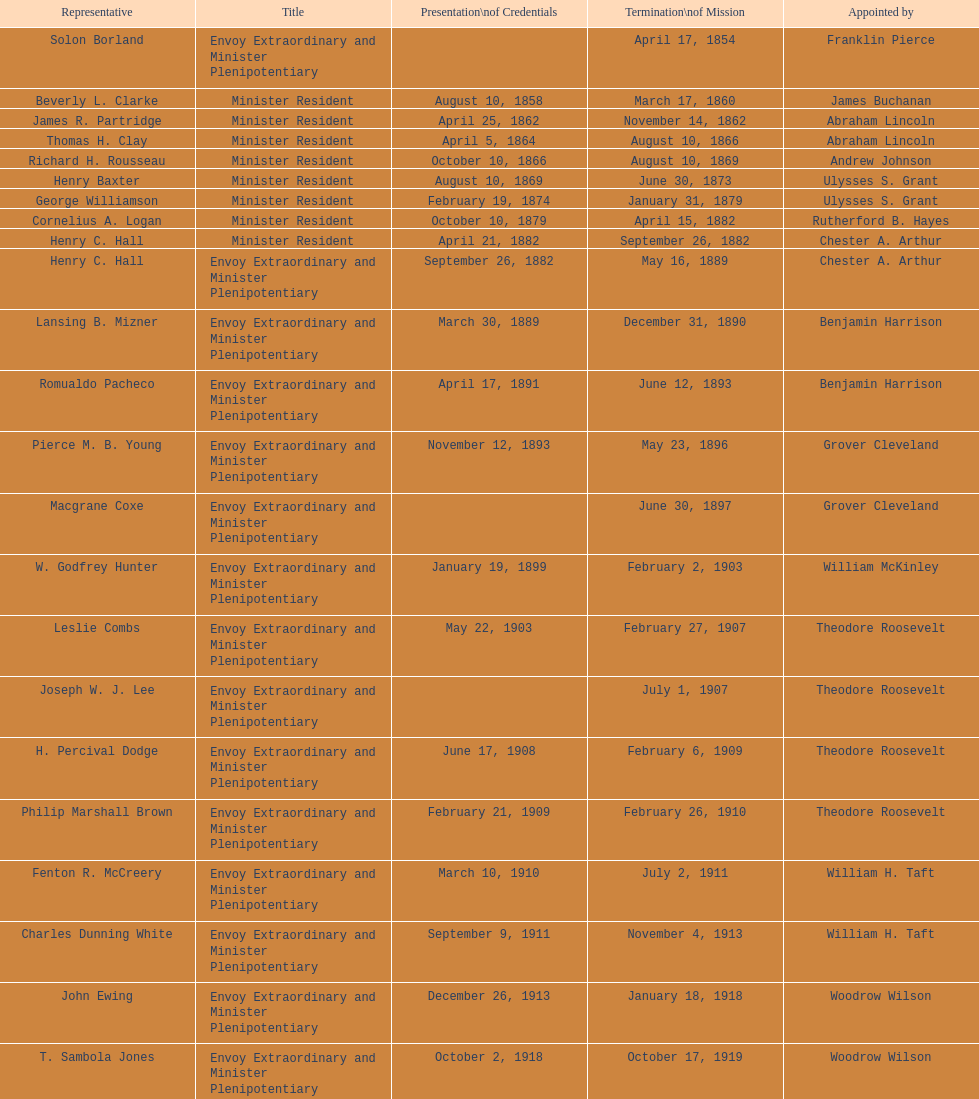Help me parse the entirety of this table. {'header': ['Representative', 'Title', 'Presentation\\nof Credentials', 'Termination\\nof Mission', 'Appointed by'], 'rows': [['Solon Borland', 'Envoy Extraordinary and Minister Plenipotentiary', '', 'April 17, 1854', 'Franklin Pierce'], ['Beverly L. Clarke', 'Minister Resident', 'August 10, 1858', 'March 17, 1860', 'James Buchanan'], ['James R. Partridge', 'Minister Resident', 'April 25, 1862', 'November 14, 1862', 'Abraham Lincoln'], ['Thomas H. Clay', 'Minister Resident', 'April 5, 1864', 'August 10, 1866', 'Abraham Lincoln'], ['Richard H. Rousseau', 'Minister Resident', 'October 10, 1866', 'August 10, 1869', 'Andrew Johnson'], ['Henry Baxter', 'Minister Resident', 'August 10, 1869', 'June 30, 1873', 'Ulysses S. Grant'], ['George Williamson', 'Minister Resident', 'February 19, 1874', 'January 31, 1879', 'Ulysses S. Grant'], ['Cornelius A. Logan', 'Minister Resident', 'October 10, 1879', 'April 15, 1882', 'Rutherford B. Hayes'], ['Henry C. Hall', 'Minister Resident', 'April 21, 1882', 'September 26, 1882', 'Chester A. Arthur'], ['Henry C. Hall', 'Envoy Extraordinary and Minister Plenipotentiary', 'September 26, 1882', 'May 16, 1889', 'Chester A. Arthur'], ['Lansing B. Mizner', 'Envoy Extraordinary and Minister Plenipotentiary', 'March 30, 1889', 'December 31, 1890', 'Benjamin Harrison'], ['Romualdo Pacheco', 'Envoy Extraordinary and Minister Plenipotentiary', 'April 17, 1891', 'June 12, 1893', 'Benjamin Harrison'], ['Pierce M. B. Young', 'Envoy Extraordinary and Minister Plenipotentiary', 'November 12, 1893', 'May 23, 1896', 'Grover Cleveland'], ['Macgrane Coxe', 'Envoy Extraordinary and Minister Plenipotentiary', '', 'June 30, 1897', 'Grover Cleveland'], ['W. Godfrey Hunter', 'Envoy Extraordinary and Minister Plenipotentiary', 'January 19, 1899', 'February 2, 1903', 'William McKinley'], ['Leslie Combs', 'Envoy Extraordinary and Minister Plenipotentiary', 'May 22, 1903', 'February 27, 1907', 'Theodore Roosevelt'], ['Joseph W. J. Lee', 'Envoy Extraordinary and Minister Plenipotentiary', '', 'July 1, 1907', 'Theodore Roosevelt'], ['H. Percival Dodge', 'Envoy Extraordinary and Minister Plenipotentiary', 'June 17, 1908', 'February 6, 1909', 'Theodore Roosevelt'], ['Philip Marshall Brown', 'Envoy Extraordinary and Minister Plenipotentiary', 'February 21, 1909', 'February 26, 1910', 'Theodore Roosevelt'], ['Fenton R. McCreery', 'Envoy Extraordinary and Minister Plenipotentiary', 'March 10, 1910', 'July 2, 1911', 'William H. Taft'], ['Charles Dunning White', 'Envoy Extraordinary and Minister Plenipotentiary', 'September 9, 1911', 'November 4, 1913', 'William H. Taft'], ['John Ewing', 'Envoy Extraordinary and Minister Plenipotentiary', 'December 26, 1913', 'January 18, 1918', 'Woodrow Wilson'], ['T. Sambola Jones', 'Envoy Extraordinary and Minister Plenipotentiary', 'October 2, 1918', 'October 17, 1919', 'Woodrow Wilson'], ['Franklin E. Morales', 'Envoy Extraordinary and Minister Plenipotentiary', 'January 18, 1922', 'March 2, 1925', 'Warren G. Harding'], ['George T. Summerlin', 'Envoy Extraordinary and Minister Plenipotentiary', 'November 21, 1925', 'December 17, 1929', 'Calvin Coolidge'], ['Julius G. Lay', 'Envoy Extraordinary and Minister Plenipotentiary', 'May 31, 1930', 'March 17, 1935', 'Herbert Hoover'], ['Leo J. Keena', 'Envoy Extraordinary and Minister Plenipotentiary', 'July 19, 1935', 'May 1, 1937', 'Franklin D. Roosevelt'], ['John Draper Erwin', 'Envoy Extraordinary and Minister Plenipotentiary', 'September 8, 1937', 'April 27, 1943', 'Franklin D. Roosevelt'], ['John Draper Erwin', 'Ambassador Extraordinary and Plenipotentiary', 'April 27, 1943', 'April 16, 1947', 'Franklin D. Roosevelt'], ['Paul C. Daniels', 'Ambassador Extraordinary and Plenipotentiary', 'June 23, 1947', 'October 30, 1947', 'Harry S. Truman'], ['Herbert S. Bursley', 'Ambassador Extraordinary and Plenipotentiary', 'May 15, 1948', 'December 12, 1950', 'Harry S. Truman'], ['John Draper Erwin', 'Ambassador Extraordinary and Plenipotentiary', 'March 14, 1951', 'February 28, 1954', 'Harry S. Truman'], ['Whiting Willauer', 'Ambassador Extraordinary and Plenipotentiary', 'March 5, 1954', 'March 24, 1958', 'Dwight D. Eisenhower'], ['Robert Newbegin', 'Ambassador Extraordinary and Plenipotentiary', 'April 30, 1958', 'August 3, 1960', 'Dwight D. Eisenhower'], ['Charles R. Burrows', 'Ambassador Extraordinary and Plenipotentiary', 'November 3, 1960', 'June 28, 1965', 'Dwight D. Eisenhower'], ['Joseph J. Jova', 'Ambassador Extraordinary and Plenipotentiary', 'July 12, 1965', 'June 21, 1969', 'Lyndon B. Johnson'], ['Hewson A. Ryan', 'Ambassador Extraordinary and Plenipotentiary', 'November 5, 1969', 'May 30, 1973', 'Richard Nixon'], ['Phillip V. Sanchez', 'Ambassador Extraordinary and Plenipotentiary', 'June 15, 1973', 'July 17, 1976', 'Richard Nixon'], ['Ralph E. Becker', 'Ambassador Extraordinary and Plenipotentiary', 'October 27, 1976', 'August 1, 1977', 'Gerald Ford'], ['Mari-Luci Jaramillo', 'Ambassador Extraordinary and Plenipotentiary', 'October 27, 1977', 'September 19, 1980', 'Jimmy Carter'], ['Jack R. Binns', 'Ambassador Extraordinary and Plenipotentiary', 'October 10, 1980', 'October 31, 1981', 'Jimmy Carter'], ['John D. Negroponte', 'Ambassador Extraordinary and Plenipotentiary', 'November 11, 1981', 'May 30, 1985', 'Ronald Reagan'], ['John Arthur Ferch', 'Ambassador Extraordinary and Plenipotentiary', 'August 22, 1985', 'July 9, 1986', 'Ronald Reagan'], ['Everett Ellis Briggs', 'Ambassador Extraordinary and Plenipotentiary', 'November 4, 1986', 'June 15, 1989', 'Ronald Reagan'], ['Cresencio S. Arcos, Jr.', 'Ambassador Extraordinary and Plenipotentiary', 'January 29, 1990', 'July 1, 1993', 'George H. W. Bush'], ['William Thornton Pryce', 'Ambassador Extraordinary and Plenipotentiary', 'July 21, 1993', 'August 15, 1996', 'Bill Clinton'], ['James F. Creagan', 'Ambassador Extraordinary and Plenipotentiary', 'August 29, 1996', 'July 20, 1999', 'Bill Clinton'], ['Frank Almaguer', 'Ambassador Extraordinary and Plenipotentiary', 'August 25, 1999', 'September 5, 2002', 'Bill Clinton'], ['Larry Leon Palmer', 'Ambassador Extraordinary and Plenipotentiary', 'October 8, 2002', 'May 7, 2005', 'George W. Bush'], ['Charles A. Ford', 'Ambassador Extraordinary and Plenipotentiary', 'November 8, 2005', 'ca. April 2008', 'George W. Bush'], ['Hugo Llorens', 'Ambassador Extraordinary and Plenipotentiary', 'September 19, 2008', 'ca. July 2011', 'George W. Bush'], ['Lisa Kubiske', 'Ambassador Extraordinary and Plenipotentiary', 'July 26, 2011', 'Incumbent', 'Barack Obama']]} Which ambassador to honduras held the position for the longest duration? Henry C. Hall. 